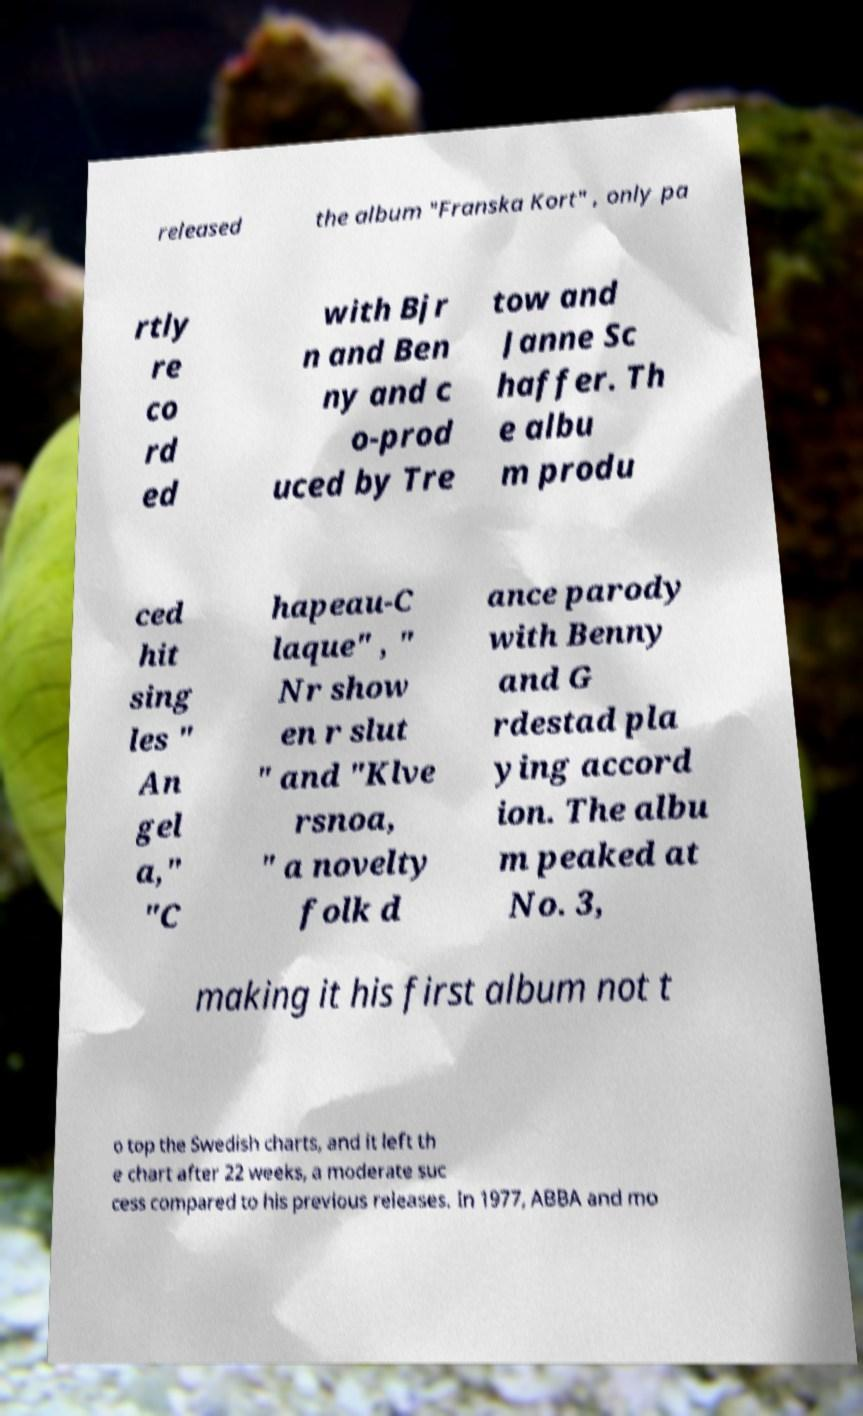Please read and relay the text visible in this image. What does it say? released the album "Franska Kort" , only pa rtly re co rd ed with Bjr n and Ben ny and c o-prod uced by Tre tow and Janne Sc haffer. Th e albu m produ ced hit sing les " An gel a," "C hapeau-C laque" , " Nr show en r slut " and "Klve rsnoa, " a novelty folk d ance parody with Benny and G rdestad pla ying accord ion. The albu m peaked at No. 3, making it his first album not t o top the Swedish charts, and it left th e chart after 22 weeks, a moderate suc cess compared to his previous releases. In 1977, ABBA and mo 